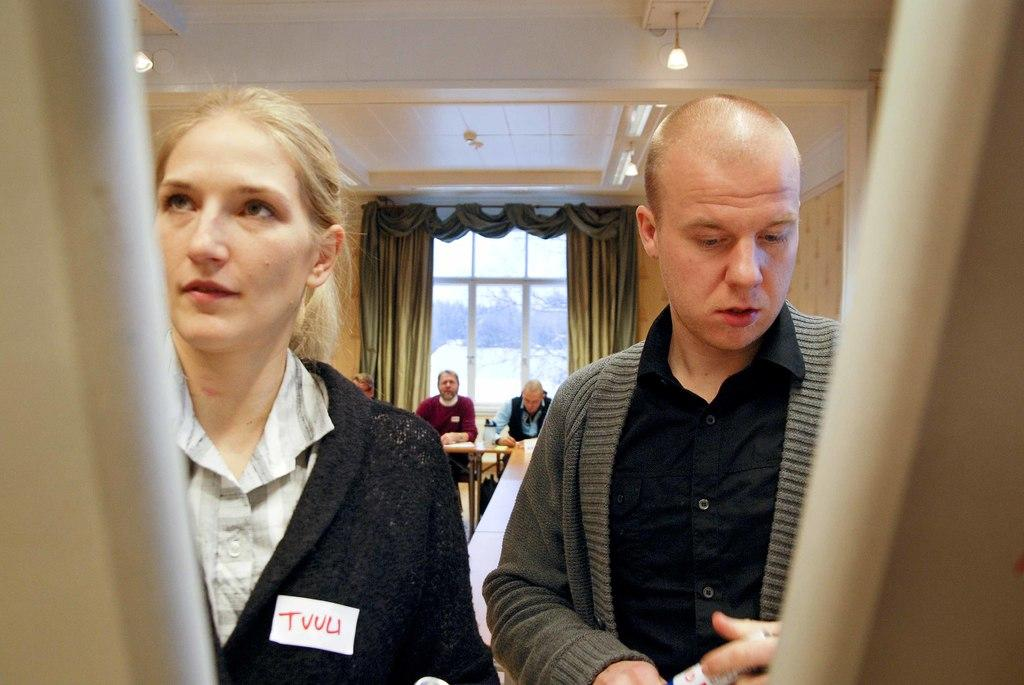What are the people in the image doing? Some people are standing, and others are sitting in the image. What can be seen behind the people? There is a curtain and a glass window visible in the image. What type of lighting is present in the image? There are lights in the image. What is the main architectural feature in the image? There is a wall in the image. What is on the table in the image? There are objects on the table. Is there a sofa in the image during the rainstorm? There is no sofa or rainstorm present in the image. Can you see a bat flying around in the image? There is no bat visible in the image. 